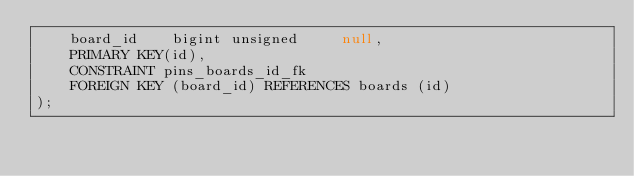<code> <loc_0><loc_0><loc_500><loc_500><_SQL_>    board_id    bigint unsigned     null,
    PRIMARY KEY(id),
    CONSTRAINT pins_boards_id_fk
    FOREIGN KEY (board_id) REFERENCES boards (id)
);
</code> 